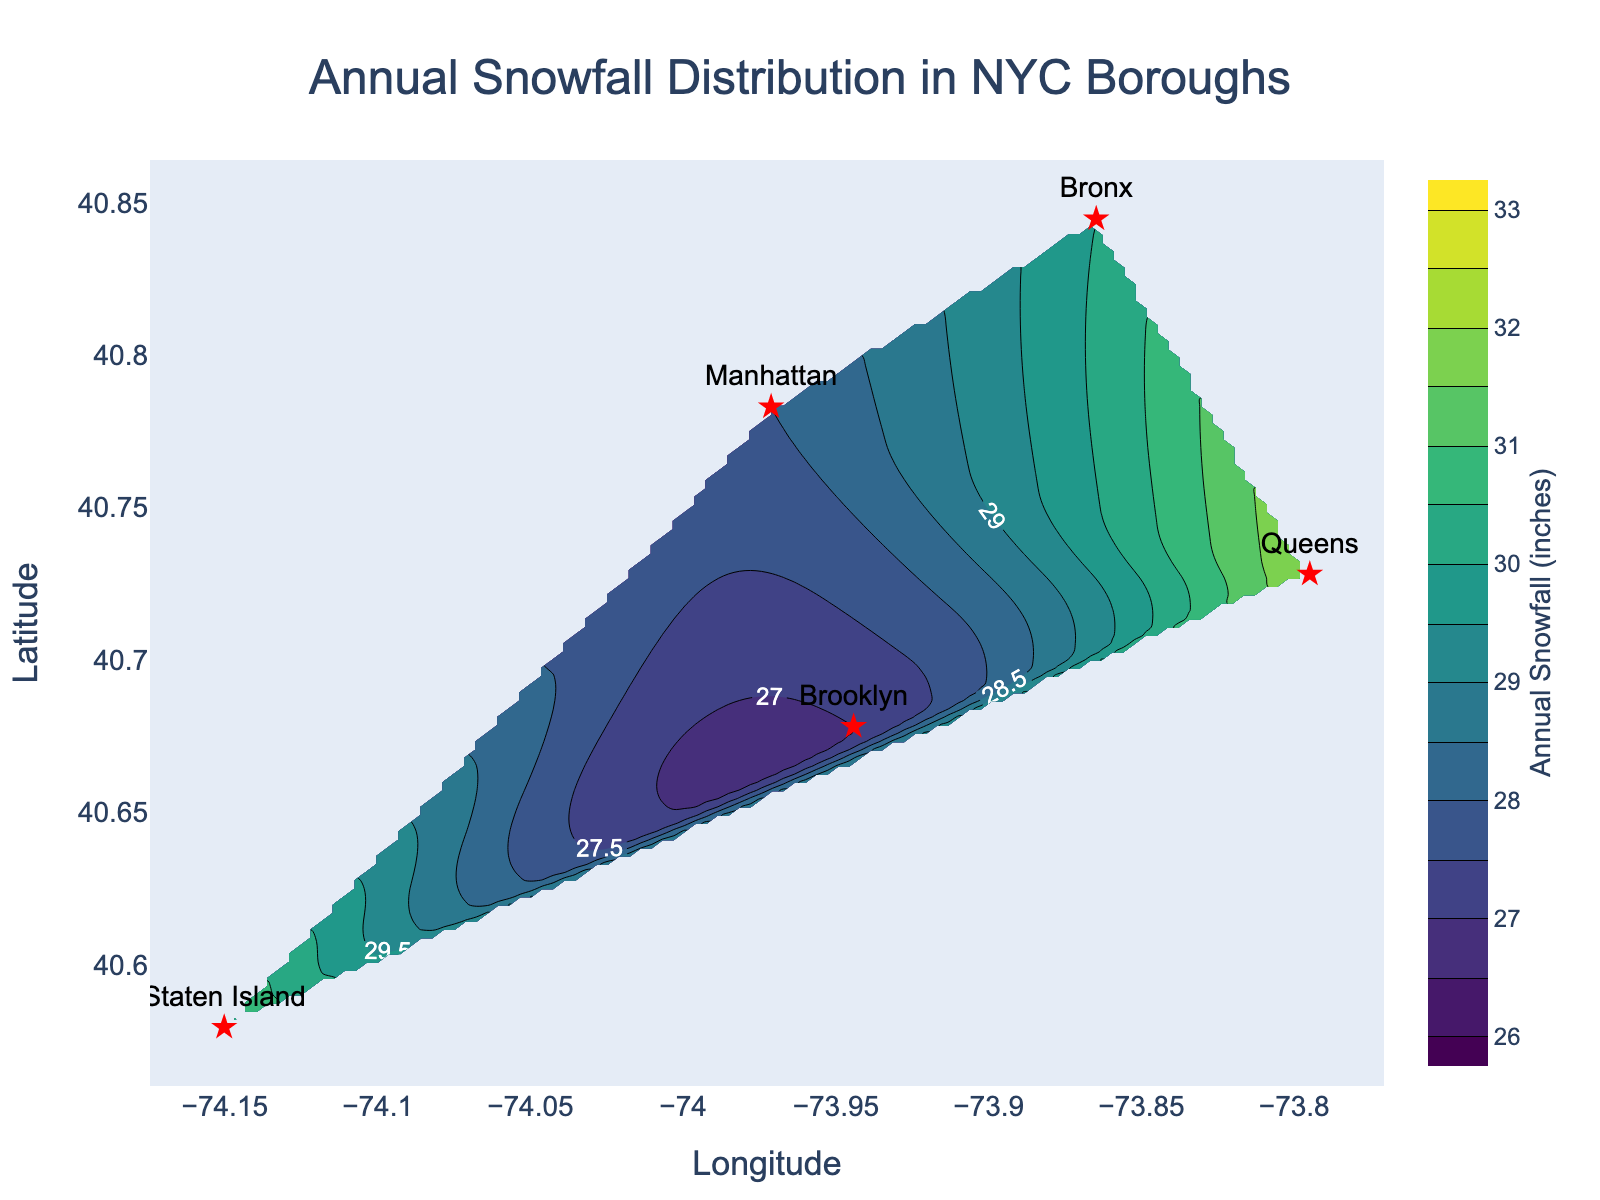What's the title of the plot? The title is usually found at the top center of the plot and provides a concise description of the plot's content.
Answer: Annual Snowfall Distribution in NYC Boroughs How is the annual snowfall distributed across the NYC boroughs in general? The contour plot shows a gradually changing color gradient, which indicates variation in snowfall distribution across different boroughs. The differences in contour lines also show varying levels of snowfall intensity.
Answer: Gradually varying with slight differences in snowfall among the boroughs Which borough has the highest annual snowfall? By examining the labeled markers and the contour lines, we see that the highest snowfall value is associated with Queens at 32 inches.
Answer: Queens Are there any areas in the plot where the annual snowfall is below 27 inches? The contour lines are labeled and start from 26 inches. Since the lowest contour value is 26 and most values are above it, there are no areas below 27 inches.
Answer: No What is the snowfall range presented in the plot? The color bar indicates the range, and the contours labeled on the plot range from 26 to 33 inches.
Answer: 26 to 33 inches What are the coordinates of the borough with the least annual snowfall? By checking the labeled markers, Brooklyn is shown to have the least snowfall at 27 inches, and its coordinates are approximately (40.6782, -73.9442).
Answer: (40.6782, -73.9442) Which borough has a higher annual snowfall, the Bronx or Staten Island? From the labeled data points, the Bronx has an annual snowfall of 30 inches, whereas Staten Island has 31 inches. Comparing these values, Staten Island has higher snowfall.
Answer: Staten Island Is there a consistent trend in snowfall from north to south in NYC? Observing the contour gradients and labeled values from north (Bronx) to south (Staten Island), there does not seem to be a clear consistent trend as Manhattan and Brooklyn also show varied snowfall amounts.
Answer: No Between Manhattan and Brooklyn, which borough has lower snowfall? By checking the individual labels for annual snowfall, Manhattan has 28 inches while Brooklyn has 27 inches. Thus, Brooklyn has a slightly lower snowfall.
Answer: Brooklyn What are the specific latitude and longitude ranges used in the plot? The axes of the plot show the latitude range from approximately 40.5795 to 40.8448 and the longitude range from about -74.15 to -73.7949.
Answer: Latitude: 40.5795 to 40.8448, Longitude: -74.15 to -73.7949 